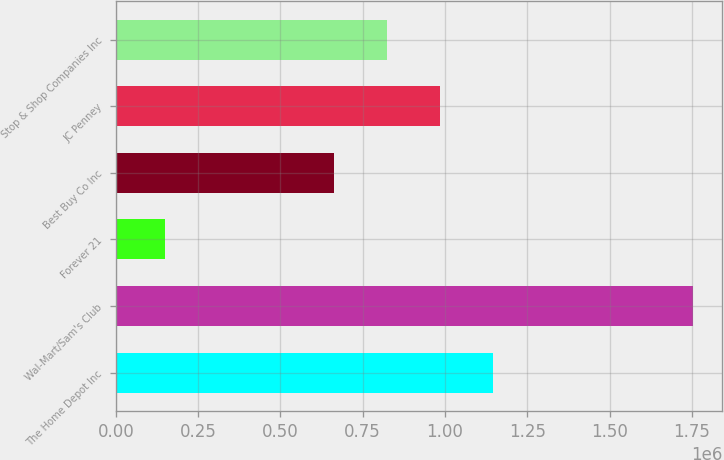Convert chart. <chart><loc_0><loc_0><loc_500><loc_500><bar_chart><fcel>The Home Depot Inc<fcel>Wal-Mart/Sam's Club<fcel>Forever 21<fcel>Best Buy Co Inc<fcel>JC Penney<fcel>Stop & Shop Companies Inc<nl><fcel>1.1455e+06<fcel>1.754e+06<fcel>149000<fcel>664000<fcel>985000<fcel>824500<nl></chart> 